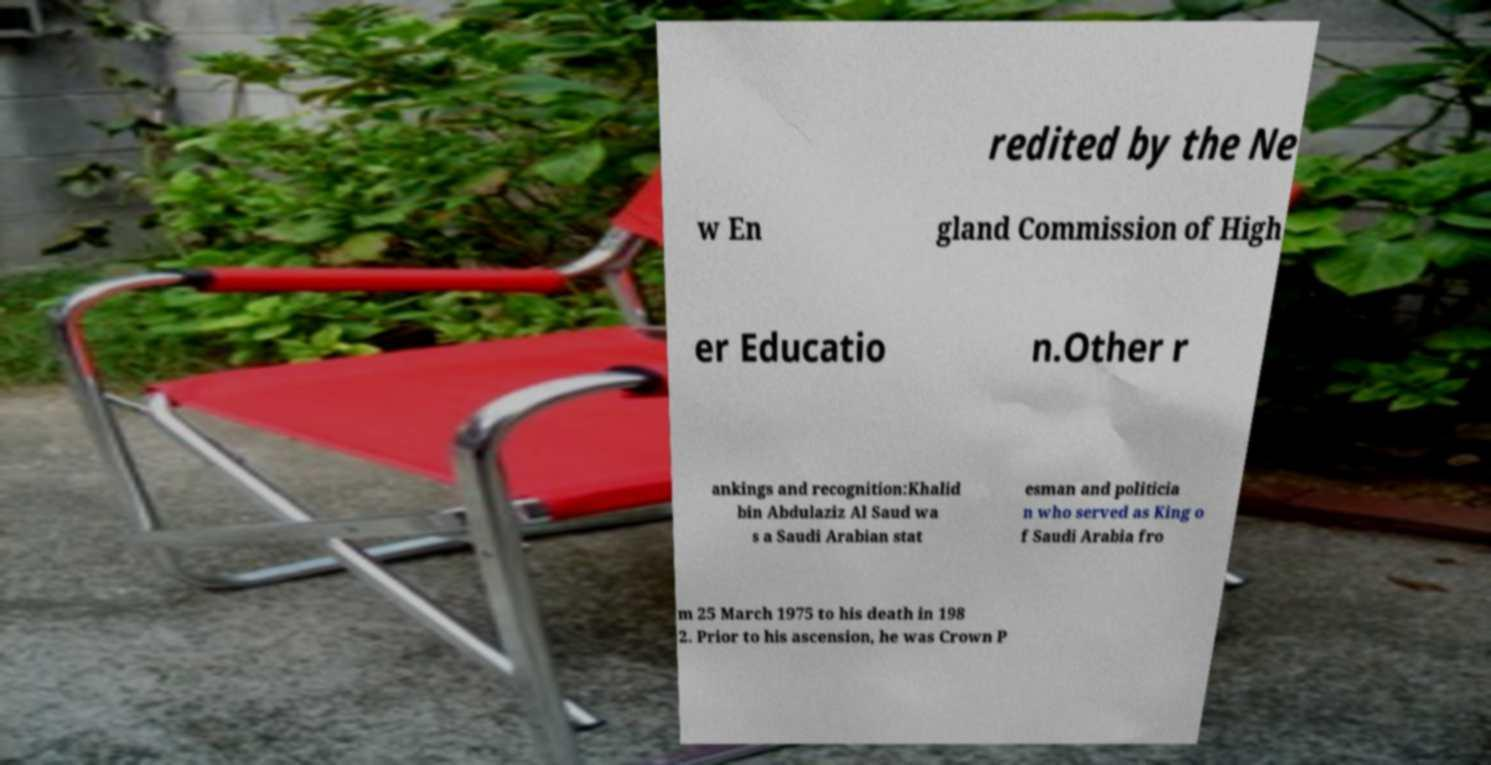There's text embedded in this image that I need extracted. Can you transcribe it verbatim? redited by the Ne w En gland Commission of High er Educatio n.Other r ankings and recognition:Khalid bin Abdulaziz Al Saud wa s a Saudi Arabian stat esman and politicia n who served as King o f Saudi Arabia fro m 25 March 1975 to his death in 198 2. Prior to his ascension, he was Crown P 